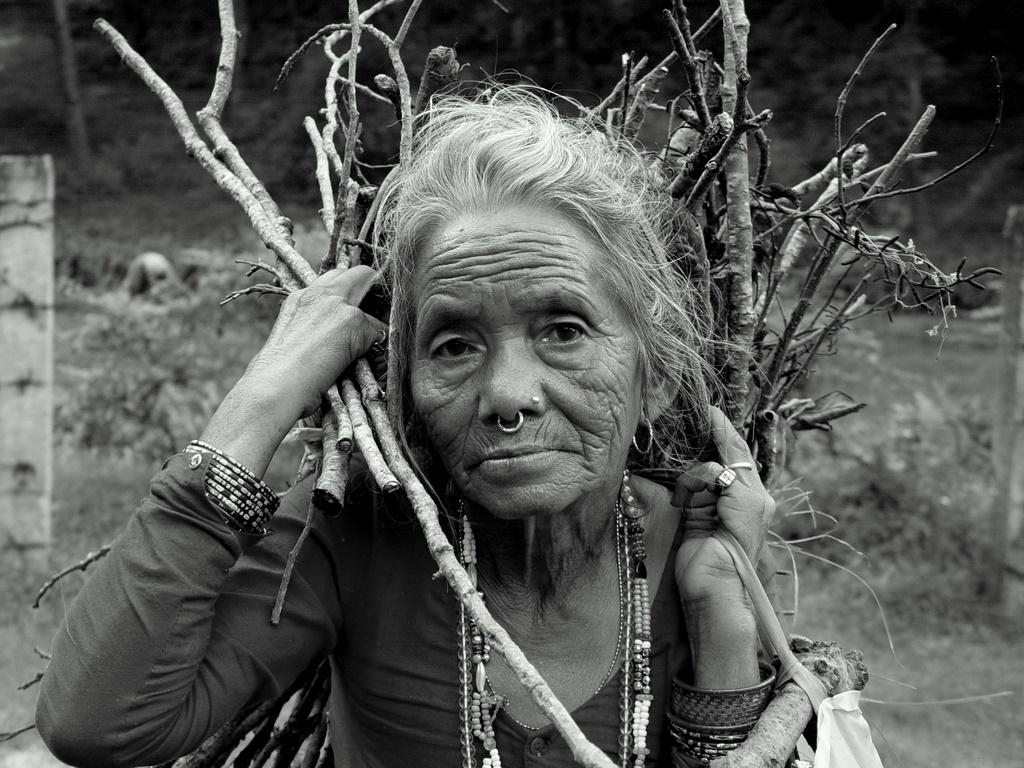What is the main subject of the image? There is a person in the image. What is the person holding in the image? The person is holding sticks. What type of clothing or accessories is the person wearing? The person is wearing chains. What is the color scheme of the image? The image is in black and white. What type of pickle can be seen on the desk in the image? There is no pickle or desk present in the image; it features a person holding sticks and wearing chains. What type of cable is connected to the person in the image? There is no cable connected to the person in the image; they are wearing chains. 